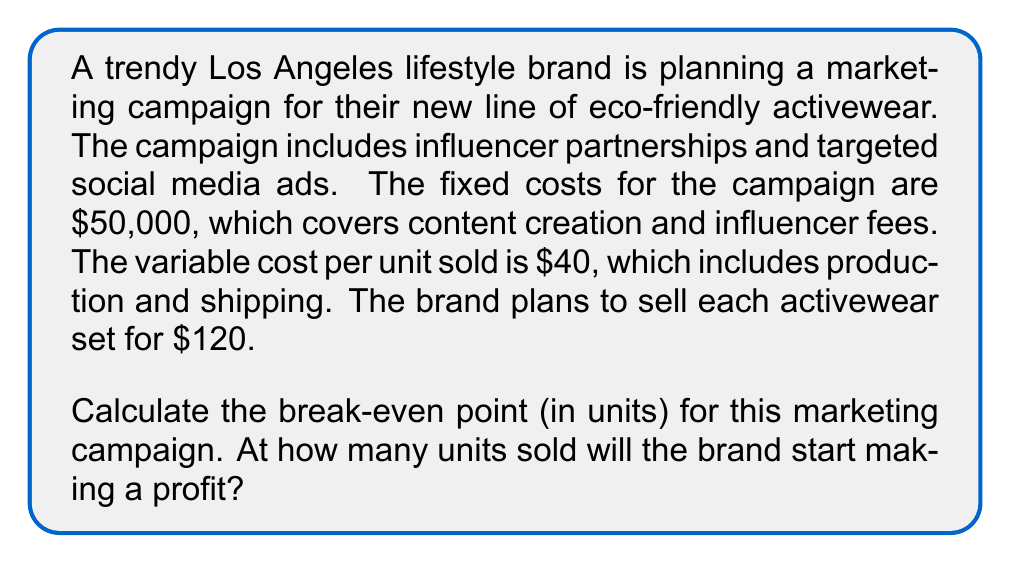Can you answer this question? To calculate the break-even point, we need to determine the number of units that need to be sold for the total revenue to equal the total costs. Let's break this down step-by-step:

1. Define the variables:
   Let $x$ = number of units sold
   
2. Express the total revenue (TR) and total costs (TC) in terms of $x$:
   TR = Price per unit × Number of units sold
   TR = $120x$
   
   TC = Fixed costs + (Variable cost per unit × Number of units sold)
   TC = $50,000 + $40x$

3. At the break-even point, TR = TC:
   $120x = 50,000 + 40x$

4. Solve the equation:
   $120x - 40x = 50,000$
   $80x = 50,000$
   
   $$x = \frac{50,000}{80} = 625$$

Therefore, the brand needs to sell 625 units to break even.

To verify:
At 625 units:
Revenue = $120 × 625 = $75,000
Costs = $50,000 + ($40 × 625) = $75,000

Revenue equals costs, confirming the break-even point.
Answer: The break-even point for the marketing campaign is 625 units. The lifestyle brand will start making a profit after selling more than 625 activewear sets. 